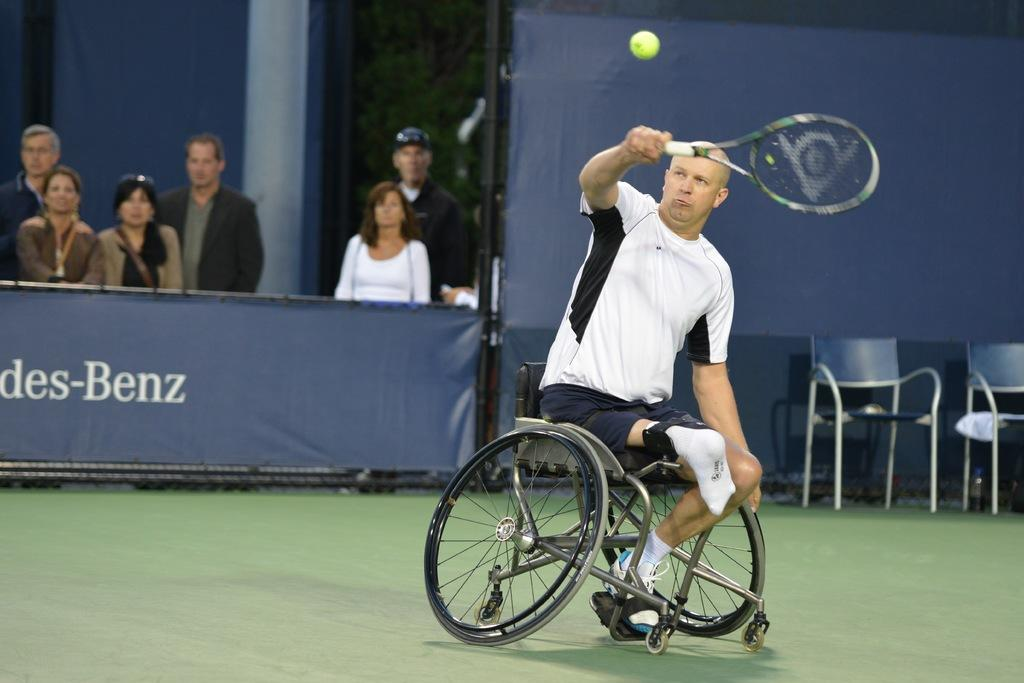What is the man in the image doing? The man is playing a tennis racket game in the image. How is the man positioned in the image? The man is sitting in a wheelchair in the image. What can be seen in the background of the image? There is a group of people, a hoarding, chairs, and a tree in the background of the image. What type of sticks are the toys made of in the image? There are no toys or sticks present in the image. How does the man control the game in the image? The image does not show the man controlling the game; it only shows him playing the tennis racket game. 